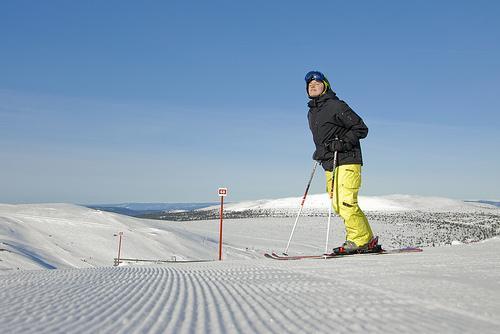How many humans are in this picture?
Give a very brief answer. 1. 